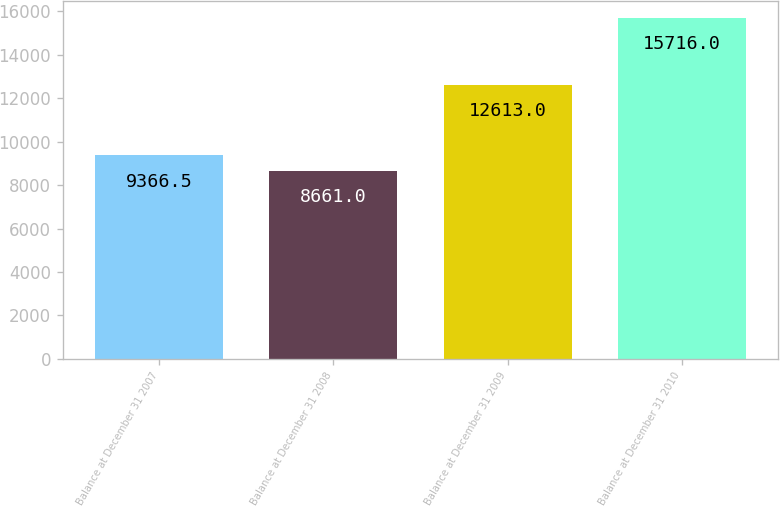Convert chart. <chart><loc_0><loc_0><loc_500><loc_500><bar_chart><fcel>Balance at December 31 2007<fcel>Balance at December 31 2008<fcel>Balance at December 31 2009<fcel>Balance at December 31 2010<nl><fcel>9366.5<fcel>8661<fcel>12613<fcel>15716<nl></chart> 